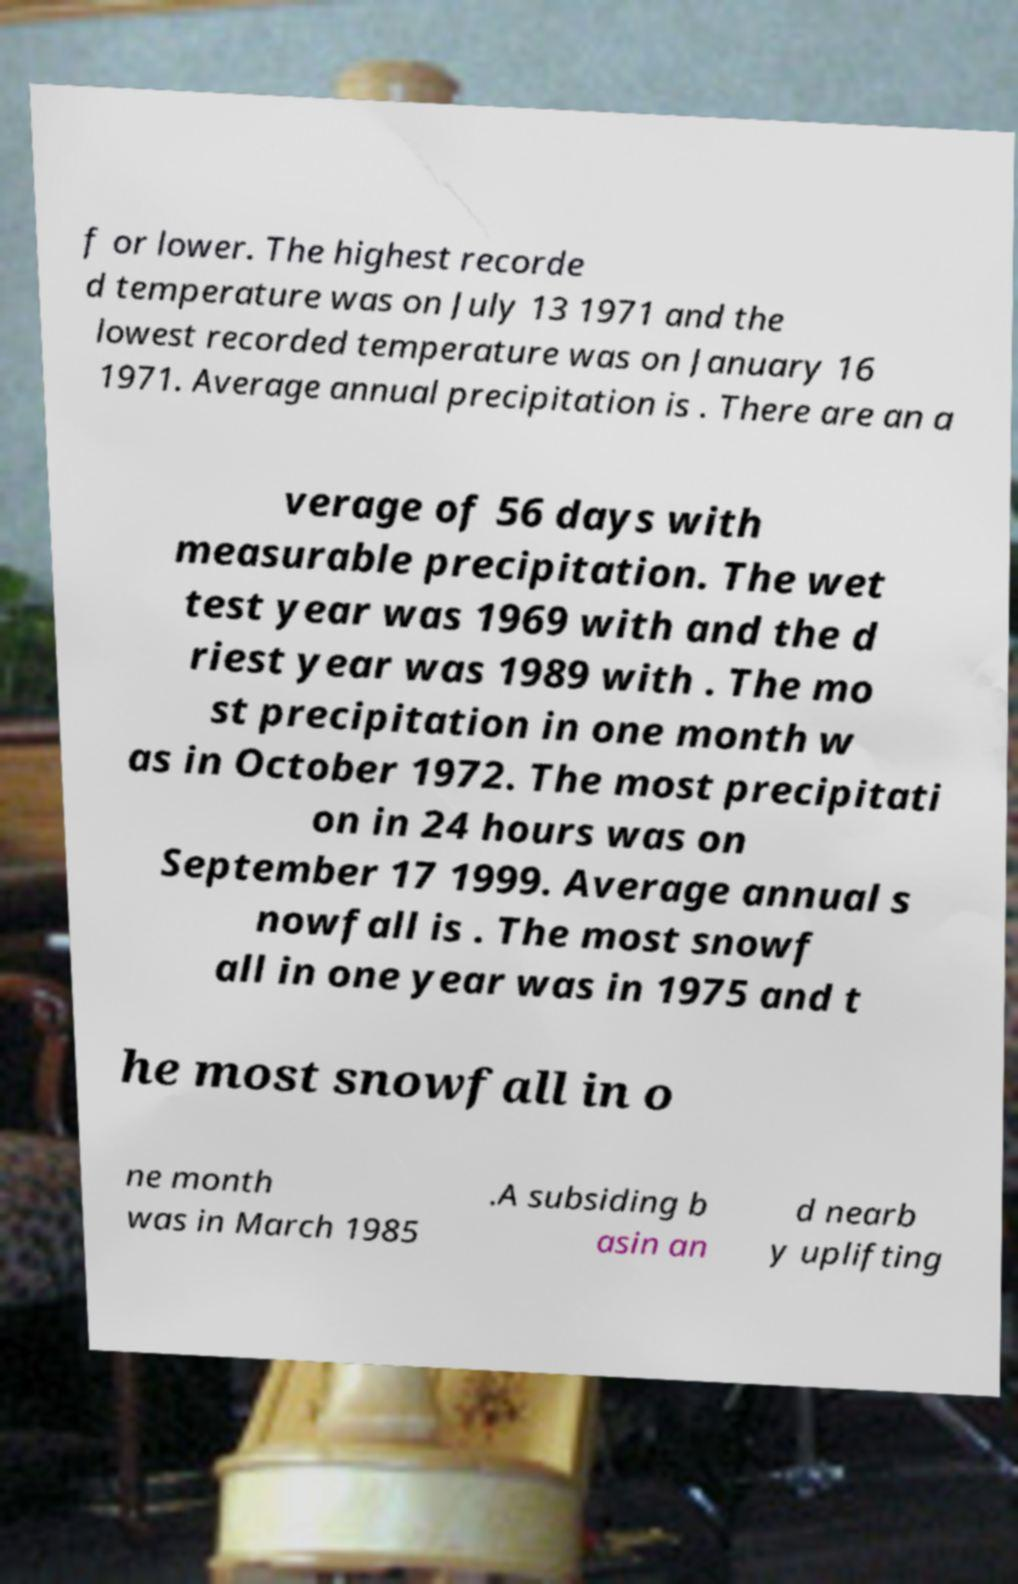What messages or text are displayed in this image? I need them in a readable, typed format. f or lower. The highest recorde d temperature was on July 13 1971 and the lowest recorded temperature was on January 16 1971. Average annual precipitation is . There are an a verage of 56 days with measurable precipitation. The wet test year was 1969 with and the d riest year was 1989 with . The mo st precipitation in one month w as in October 1972. The most precipitati on in 24 hours was on September 17 1999. Average annual s nowfall is . The most snowf all in one year was in 1975 and t he most snowfall in o ne month was in March 1985 .A subsiding b asin an d nearb y uplifting 